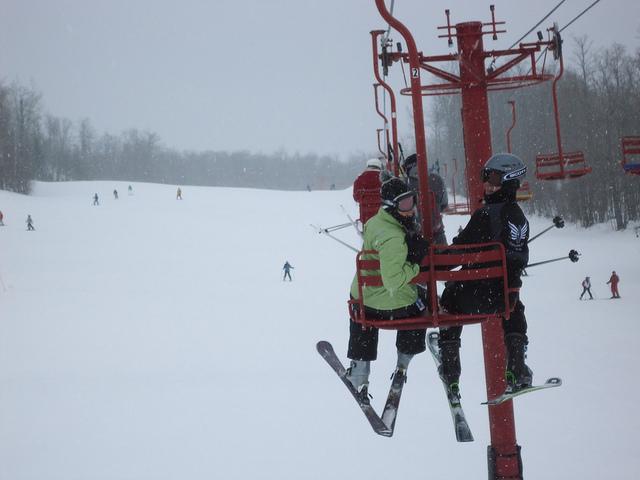How many are on the ski lift?
Short answer required. 4. What color is the jacket on the left?
Quick response, please. Green. How many people are on the ski lift?
Concise answer only. 4. Is this a ski lift?
Keep it brief. Yes. Is this and overcast day?
Be succinct. Yes. 